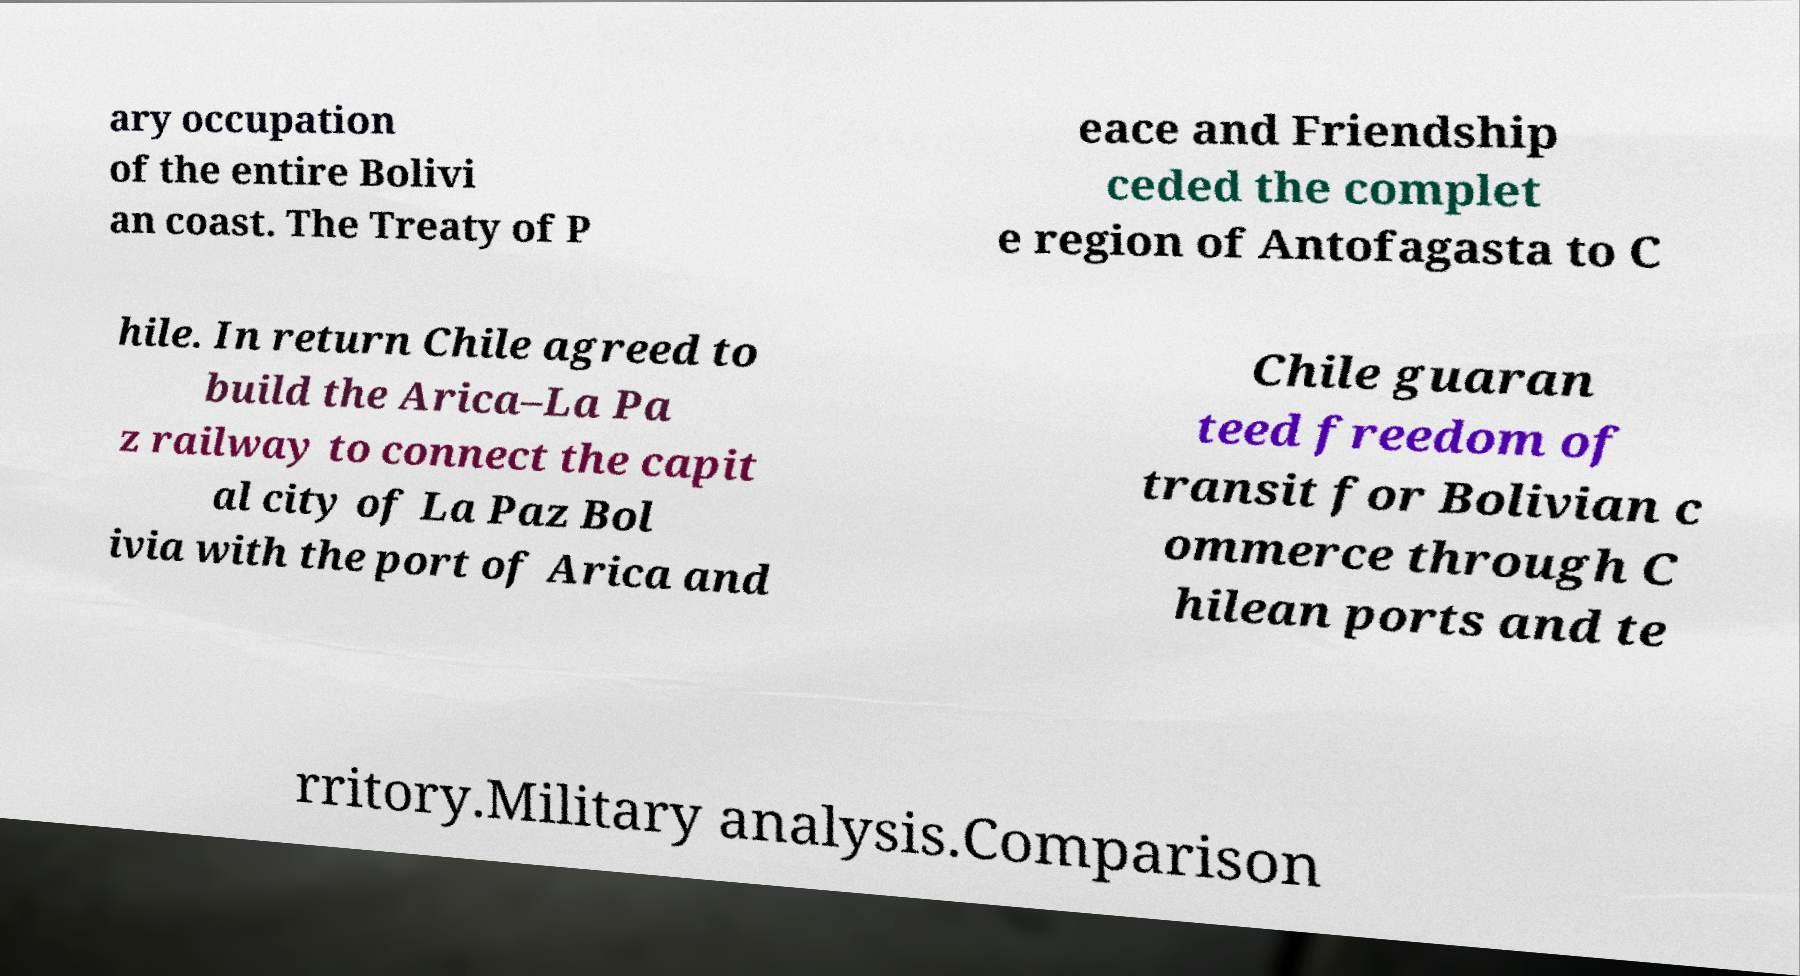Could you extract and type out the text from this image? ary occupation of the entire Bolivi an coast. The Treaty of P eace and Friendship ceded the complet e region of Antofagasta to C hile. In return Chile agreed to build the Arica–La Pa z railway to connect the capit al city of La Paz Bol ivia with the port of Arica and Chile guaran teed freedom of transit for Bolivian c ommerce through C hilean ports and te rritory.Military analysis.Comparison 